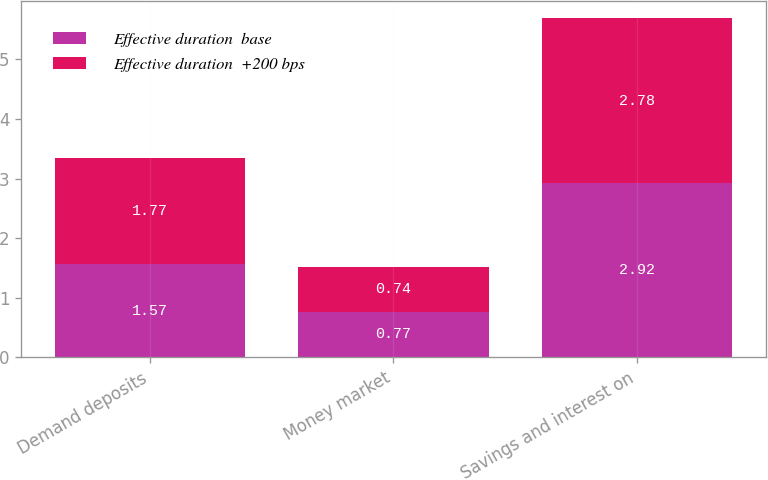<chart> <loc_0><loc_0><loc_500><loc_500><stacked_bar_chart><ecel><fcel>Demand deposits<fcel>Money market<fcel>Savings and interest on<nl><fcel>Effective duration  base<fcel>1.57<fcel>0.77<fcel>2.92<nl><fcel>Effective duration  +200 bps<fcel>1.77<fcel>0.74<fcel>2.78<nl></chart> 